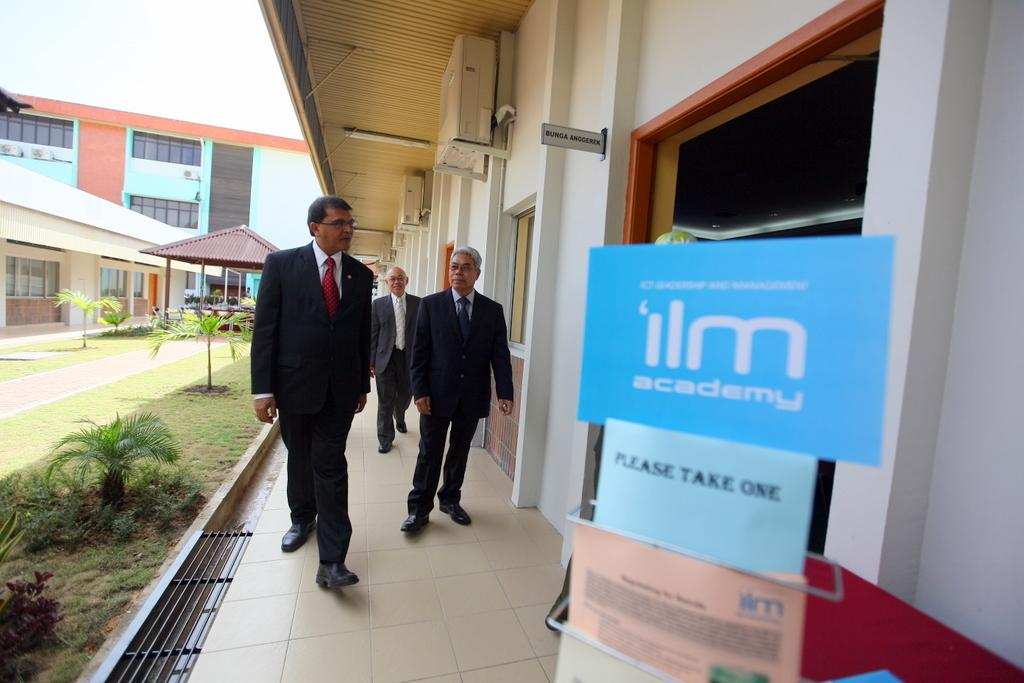<image>
Write a terse but informative summary of the picture. Three men walking to a blue placard card with ilm academy in white letters. 